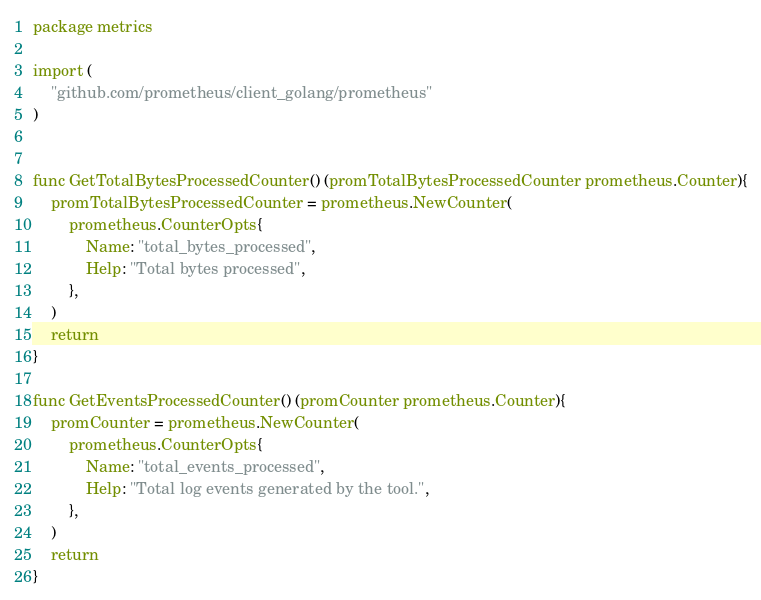Convert code to text. <code><loc_0><loc_0><loc_500><loc_500><_Go_>package metrics

import (
	"github.com/prometheus/client_golang/prometheus"
)


func GetTotalBytesProcessedCounter() (promTotalBytesProcessedCounter prometheus.Counter){
	promTotalBytesProcessedCounter = prometheus.NewCounter(
		prometheus.CounterOpts{
			Name: "total_bytes_processed",
			Help: "Total bytes processed",
		},
	)
	return
}

func GetEventsProcessedCounter() (promCounter prometheus.Counter){
	promCounter = prometheus.NewCounter(
		prometheus.CounterOpts{
			Name: "total_events_processed",
			Help: "Total log events generated by the tool.",
		},
	)
	return
}</code> 